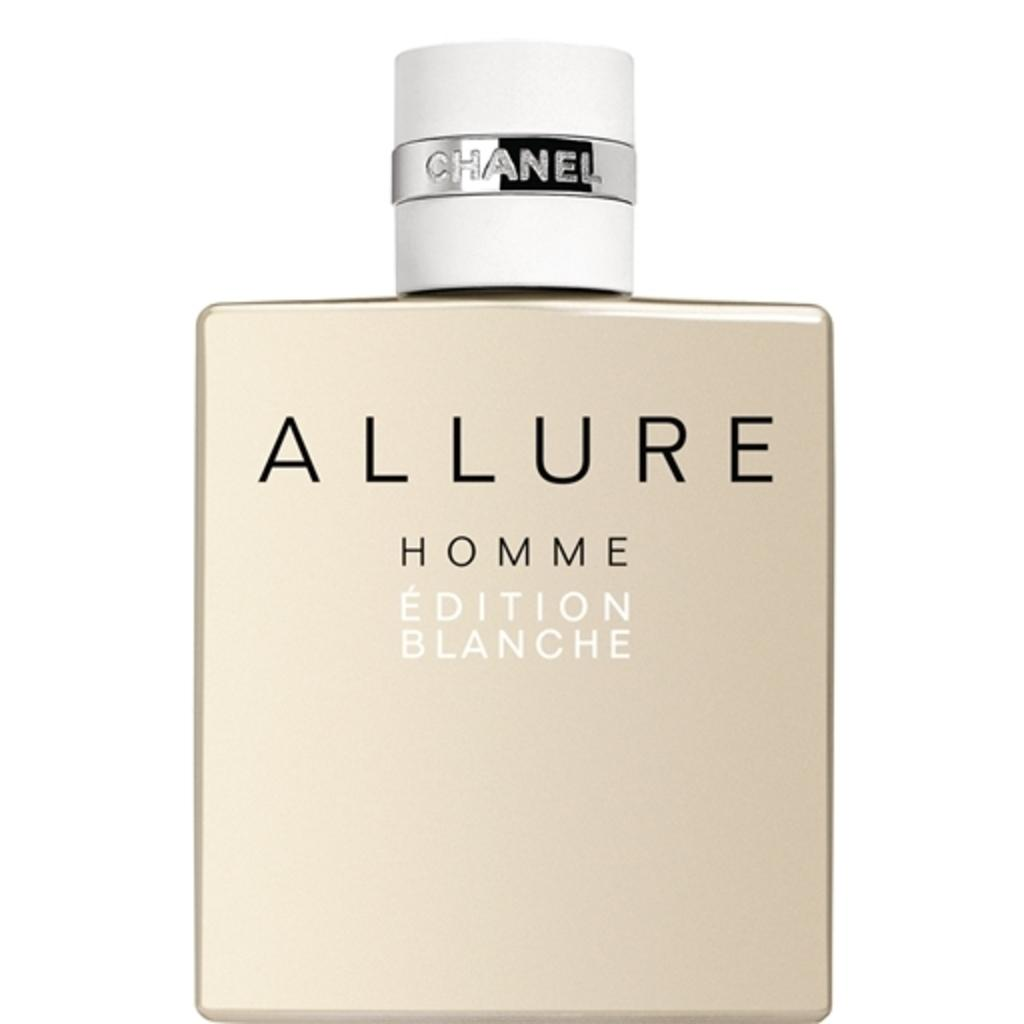<image>
Write a terse but informative summary of the picture. A bottle of perfume called Allure by Chanel. 